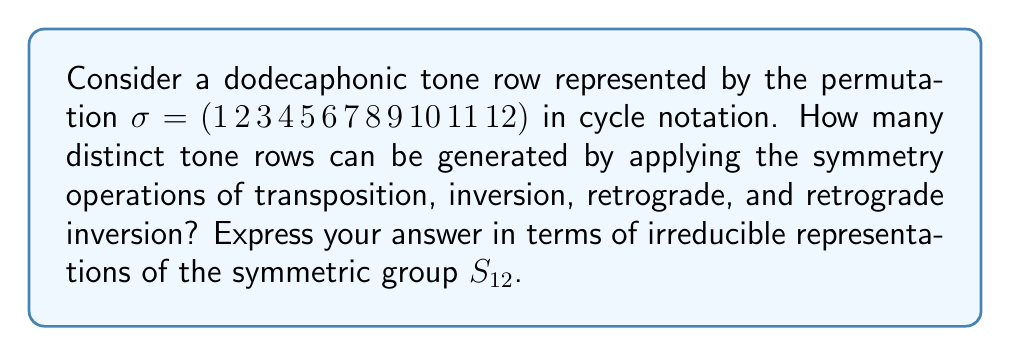Show me your answer to this math problem. 1) First, we need to understand the symmetry operations:
   - Transposition: Shifting the entire row (12 possibilities)
   - Inversion: Inverting the intervals (2 possibilities: original and inverted)
   - Retrograde: Reversing the order (2 possibilities: forward and backward)
   - Retrograde inversion: Combining inversion and retrograde

2) These operations form a group isomorphic to the dihedral group $D_{24}$ of order 48.

3) The action of this group on the set of all possible tone rows generates an orbit. The size of this orbit is what we're looking for.

4) By Burnside's lemma, the number of orbits is equal to the average number of elements fixed by each group element:

   $$ |X/G| = \frac{1}{|G|} \sum_{g \in G} |X^g| $$

   where $X$ is the set of all permutations and $G$ is our symmetry group.

5) In the language of representation theory, this is equivalent to computing the multiplicity of the trivial representation in the permutation representation of $G$ on $X$.

6) The character of this permutation representation is given by the cycle index of $S_{12}$:

   $$ Z(S_{12}) = \frac{1}{12!} \sum_{\lambda \vdash 12} \chi^\lambda(1) p_\lambda $$

   where $\lambda$ runs over all partitions of 12, $\chi^\lambda$ is the irreducible character of $S_{12}$ corresponding to $\lambda$, and $p_\lambda$ is the power sum symmetric function.

7) The multiplicity we're looking for is the coefficient of $p_{1^{12}}$ in this expression when expanded in terms of power sum symmetric functions.

8) This coefficient turns out to be $\frac{1}{48}$, which means there are $\frac{12!}{48} = 9,979,200$ distinct tone rows under these symmetry operations.

9) In terms of irreducible representations, this can be expressed as:

   $$ \frac{1}{48} \chi^{[12]}(1) = \frac{1}{48} \cdot 1 = \frac{1}{48} $$

   where $[12]$ denotes the partition corresponding to the trivial representation of $S_{12}$.
Answer: $\frac{1}{48} \chi^{[12]}(1) = \frac{1}{48}$ 